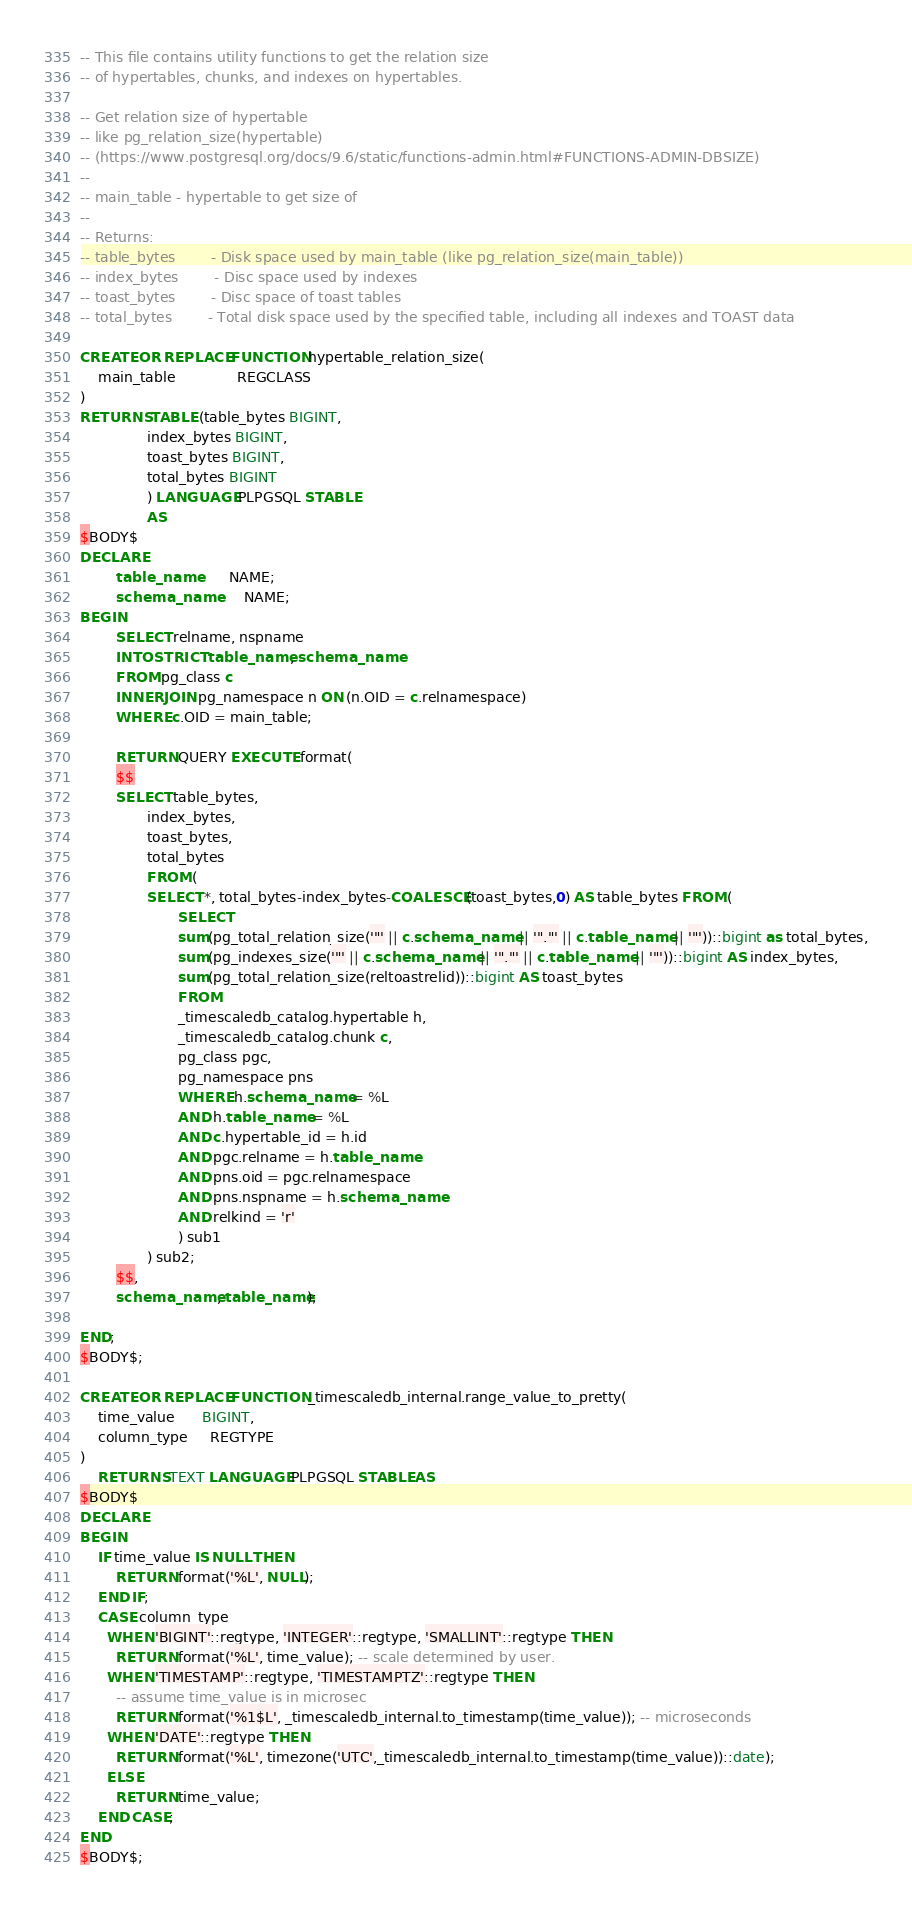<code> <loc_0><loc_0><loc_500><loc_500><_SQL_>-- This file contains utility functions to get the relation size
-- of hypertables, chunks, and indexes on hypertables.

-- Get relation size of hypertable
-- like pg_relation_size(hypertable)
-- (https://www.postgresql.org/docs/9.6/static/functions-admin.html#FUNCTIONS-ADMIN-DBSIZE)
--
-- main_table - hypertable to get size of
--
-- Returns:
-- table_bytes        - Disk space used by main_table (like pg_relation_size(main_table))
-- index_bytes        - Disc space used by indexes
-- toast_bytes        - Disc space of toast tables
-- total_bytes        - Total disk space used by the specified table, including all indexes and TOAST data

CREATE OR REPLACE FUNCTION hypertable_relation_size(
    main_table              REGCLASS
)
RETURNS TABLE (table_bytes BIGINT,
               index_bytes BIGINT,
               toast_bytes BIGINT,
               total_bytes BIGINT
               ) LANGUAGE PLPGSQL STABLE
               AS
$BODY$
DECLARE
        table_name       NAME;
        schema_name      NAME;
BEGIN
        SELECT relname, nspname
        INTO STRICT table_name, schema_name
        FROM pg_class c
        INNER JOIN pg_namespace n ON (n.OID = c.relnamespace)
        WHERE c.OID = main_table;

        RETURN QUERY EXECUTE format(
        $$
        SELECT table_bytes,
               index_bytes,
               toast_bytes,
               total_bytes
               FROM (
               SELECT *, total_bytes-index_bytes-COALESCE(toast_bytes,0) AS table_bytes FROM (
                      SELECT
                      sum(pg_total_relation_size('"' || c.schema_name || '"."' || c.table_name || '"'))::bigint as total_bytes,
                      sum(pg_indexes_size('"' || c.schema_name || '"."' || c.table_name || '"'))::bigint AS index_bytes,
                      sum(pg_total_relation_size(reltoastrelid))::bigint AS toast_bytes
                      FROM
                      _timescaledb_catalog.hypertable h,
                      _timescaledb_catalog.chunk c,
                      pg_class pgc,
                      pg_namespace pns
                      WHERE h.schema_name = %L
                      AND h.table_name = %L
                      AND c.hypertable_id = h.id
                      AND pgc.relname = h.table_name
                      AND pns.oid = pgc.relnamespace
                      AND pns.nspname = h.schema_name
                      AND relkind = 'r'
                      ) sub1
               ) sub2;
        $$,
        schema_name, table_name);

END;
$BODY$;

CREATE OR REPLACE FUNCTION _timescaledb_internal.range_value_to_pretty(
    time_value      BIGINT,
    column_type     REGTYPE
)
    RETURNS TEXT LANGUAGE PLPGSQL STABLE AS
$BODY$
DECLARE
BEGIN
    IF time_value IS NULL THEN
        RETURN format('%L', NULL);
    END IF;
    CASE column_type
      WHEN 'BIGINT'::regtype, 'INTEGER'::regtype, 'SMALLINT'::regtype THEN
        RETURN format('%L', time_value); -- scale determined by user.
      WHEN 'TIMESTAMP'::regtype, 'TIMESTAMPTZ'::regtype THEN
        -- assume time_value is in microsec
        RETURN format('%1$L', _timescaledb_internal.to_timestamp(time_value)); -- microseconds
      WHEN 'DATE'::regtype THEN
        RETURN format('%L', timezone('UTC',_timescaledb_internal.to_timestamp(time_value))::date);
      ELSE
        RETURN time_value;
    END CASE;
END
$BODY$;

</code> 